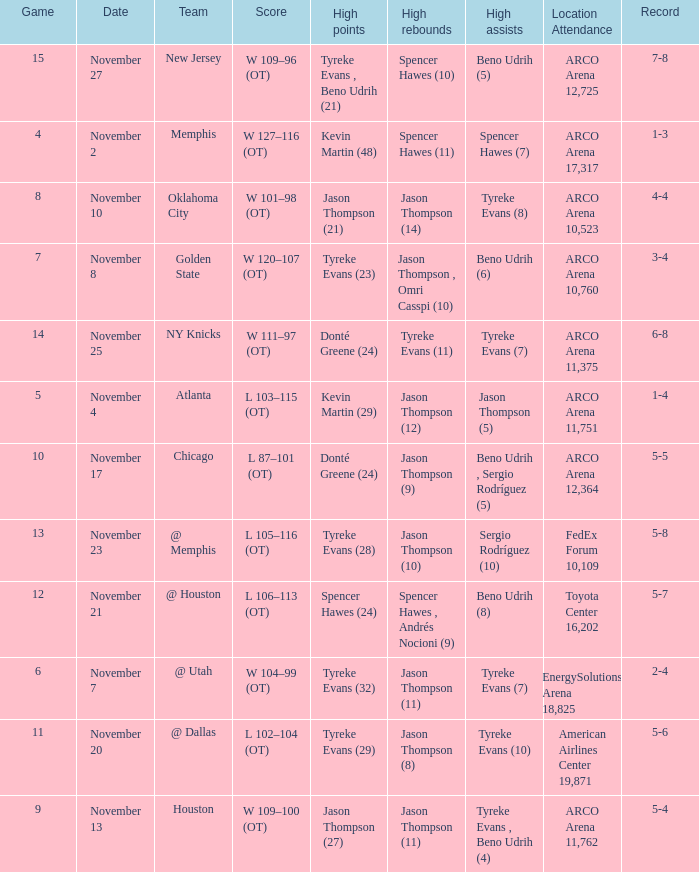If the record is 6-8, what was the score? W 111–97 (OT). 